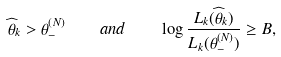<formula> <loc_0><loc_0><loc_500><loc_500>\widehat { \theta } _ { k } > \theta _ { - } ^ { ( N ) } \quad a n d \quad \log \frac { L _ { k } ( \widehat { \theta } _ { k } ) } { L _ { k } ( \theta _ { - } ^ { ( N ) } ) } \geq B ,</formula> 